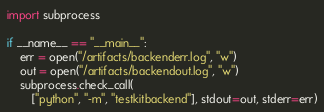<code> <loc_0><loc_0><loc_500><loc_500><_Python_>import subprocess

if __name__ == "__main__":
    err = open("/artifacts/backenderr.log", "w")
    out = open("/artifacts/backendout.log", "w")
    subprocess.check_call(
        ["python", "-m", "testkitbackend"], stdout=out, stderr=err)
</code> 